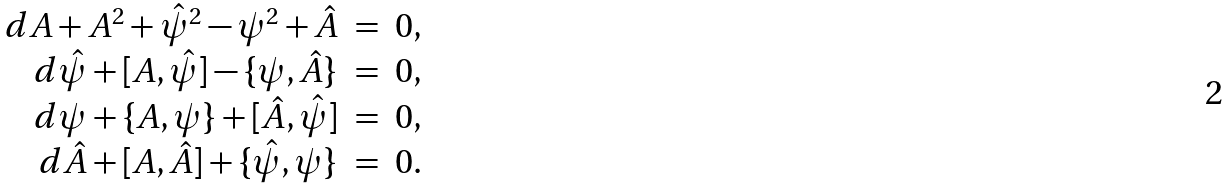Convert formula to latex. <formula><loc_0><loc_0><loc_500><loc_500>\begin{array} { r c l } { { d A + A ^ { 2 } + \hat { \psi } ^ { 2 } - \psi ^ { 2 } + \hat { A } } } & { = } & { 0 , } \\ { { d \hat { \psi } + [ A , \hat { \psi } ] - \{ \psi , \hat { A } \} } } & { = } & { 0 , } \\ { { d \psi + \{ A , \psi \} + [ \hat { A } , \hat { \psi } ] } } & { = } & { 0 , } \\ { { d \hat { A } + [ A , \hat { A } ] + \{ \hat { \psi } , \psi \} } } & { = } & { 0 . } \end{array}</formula> 